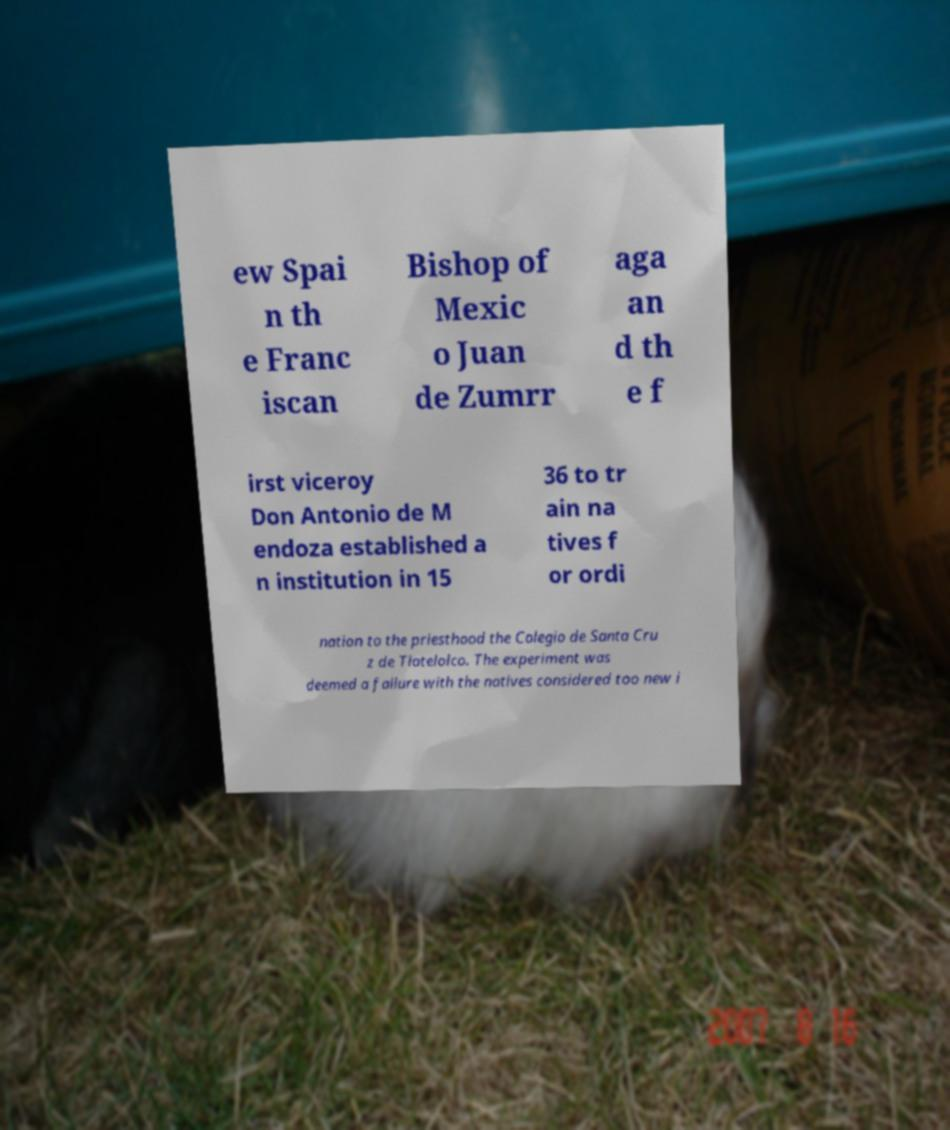I need the written content from this picture converted into text. Can you do that? ew Spai n th e Franc iscan Bishop of Mexic o Juan de Zumrr aga an d th e f irst viceroy Don Antonio de M endoza established a n institution in 15 36 to tr ain na tives f or ordi nation to the priesthood the Colegio de Santa Cru z de Tlatelolco. The experiment was deemed a failure with the natives considered too new i 